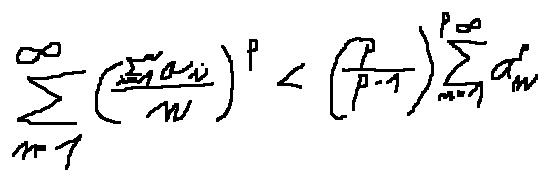Convert formula to latex. <formula><loc_0><loc_0><loc_500><loc_500>\sum \lim i t s _ { n = 1 } ^ { \infty } ( \frac { \sum \lim i t s _ { i = 1 } ^ { n } a _ { i } } { n } ) ^ { p } < ( \frac { p } { p - 1 } ) ^ { p } \sum \lim i t s _ { n = 1 } ^ { \infty } a _ { n } ^ { p }</formula> 